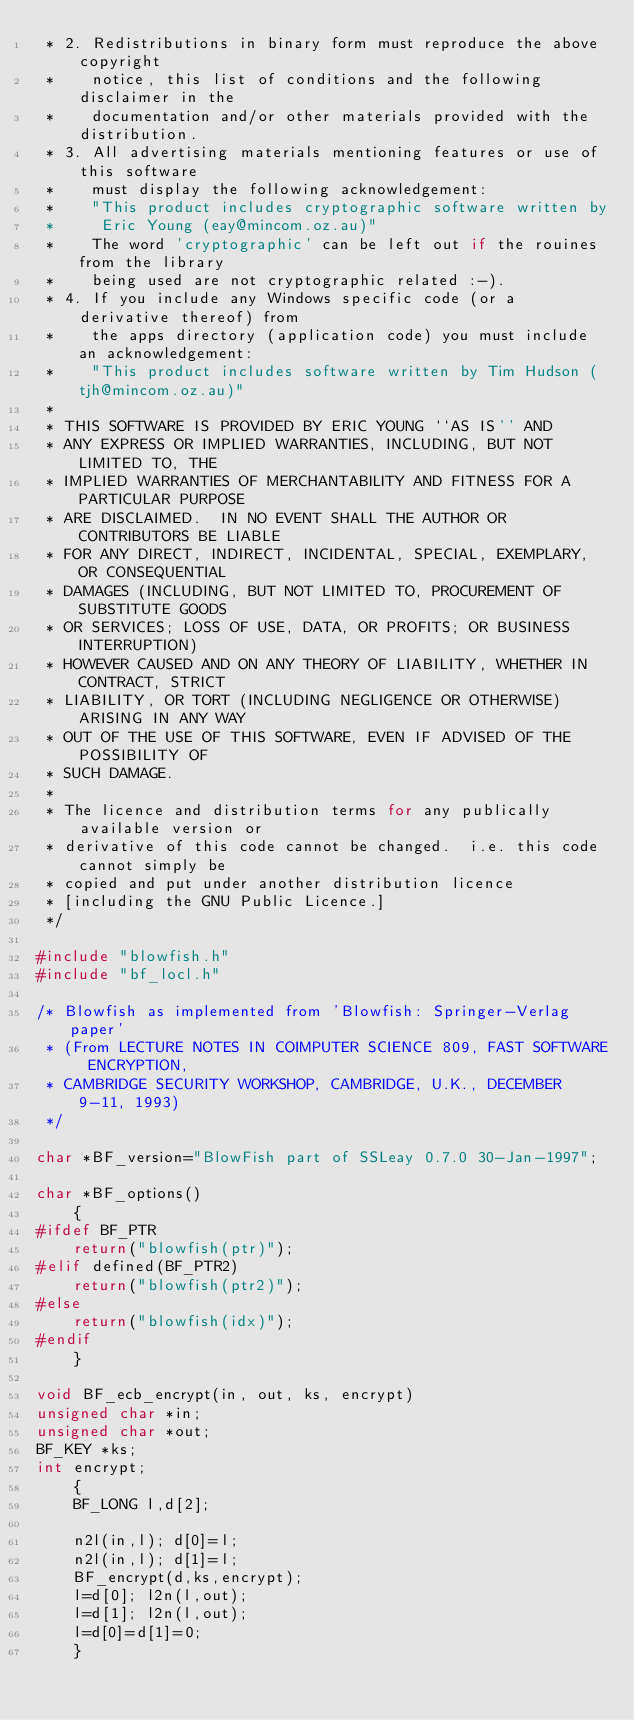Convert code to text. <code><loc_0><loc_0><loc_500><loc_500><_C_> * 2. Redistributions in binary form must reproduce the above copyright
 *    notice, this list of conditions and the following disclaimer in the
 *    documentation and/or other materials provided with the distribution.
 * 3. All advertising materials mentioning features or use of this software
 *    must display the following acknowledgement:
 *    "This product includes cryptographic software written by
 *     Eric Young (eay@mincom.oz.au)"
 *    The word 'cryptographic' can be left out if the rouines from the library
 *    being used are not cryptographic related :-).
 * 4. If you include any Windows specific code (or a derivative thereof) from 
 *    the apps directory (application code) you must include an acknowledgement:
 *    "This product includes software written by Tim Hudson (tjh@mincom.oz.au)"
 * 
 * THIS SOFTWARE IS PROVIDED BY ERIC YOUNG ``AS IS'' AND
 * ANY EXPRESS OR IMPLIED WARRANTIES, INCLUDING, BUT NOT LIMITED TO, THE
 * IMPLIED WARRANTIES OF MERCHANTABILITY AND FITNESS FOR A PARTICULAR PURPOSE
 * ARE DISCLAIMED.  IN NO EVENT SHALL THE AUTHOR OR CONTRIBUTORS BE LIABLE
 * FOR ANY DIRECT, INDIRECT, INCIDENTAL, SPECIAL, EXEMPLARY, OR CONSEQUENTIAL
 * DAMAGES (INCLUDING, BUT NOT LIMITED TO, PROCUREMENT OF SUBSTITUTE GOODS
 * OR SERVICES; LOSS OF USE, DATA, OR PROFITS; OR BUSINESS INTERRUPTION)
 * HOWEVER CAUSED AND ON ANY THEORY OF LIABILITY, WHETHER IN CONTRACT, STRICT
 * LIABILITY, OR TORT (INCLUDING NEGLIGENCE OR OTHERWISE) ARISING IN ANY WAY
 * OUT OF THE USE OF THIS SOFTWARE, EVEN IF ADVISED OF THE POSSIBILITY OF
 * SUCH DAMAGE.
 * 
 * The licence and distribution terms for any publically available version or
 * derivative of this code cannot be changed.  i.e. this code cannot simply be
 * copied and put under another distribution licence
 * [including the GNU Public Licence.]
 */

#include "blowfish.h"
#include "bf_locl.h"

/* Blowfish as implemented from 'Blowfish: Springer-Verlag paper'
 * (From LECTURE NOTES IN COIMPUTER SCIENCE 809, FAST SOFTWARE ENCRYPTION,
 * CAMBRIDGE SECURITY WORKSHOP, CAMBRIDGE, U.K., DECEMBER 9-11, 1993)
 */

char *BF_version="BlowFish part of SSLeay 0.7.0 30-Jan-1997";

char *BF_options()
	{
#ifdef BF_PTR
	return("blowfish(ptr)");
#elif defined(BF_PTR2)
	return("blowfish(ptr2)");
#else
	return("blowfish(idx)");
#endif
	}

void BF_ecb_encrypt(in, out, ks, encrypt)
unsigned char *in;
unsigned char *out;
BF_KEY *ks;
int encrypt;
	{
	BF_LONG l,d[2];

	n2l(in,l); d[0]=l;
	n2l(in,l); d[1]=l;
	BF_encrypt(d,ks,encrypt);
	l=d[0]; l2n(l,out);
	l=d[1]; l2n(l,out);
	l=d[0]=d[1]=0;
	}

</code> 